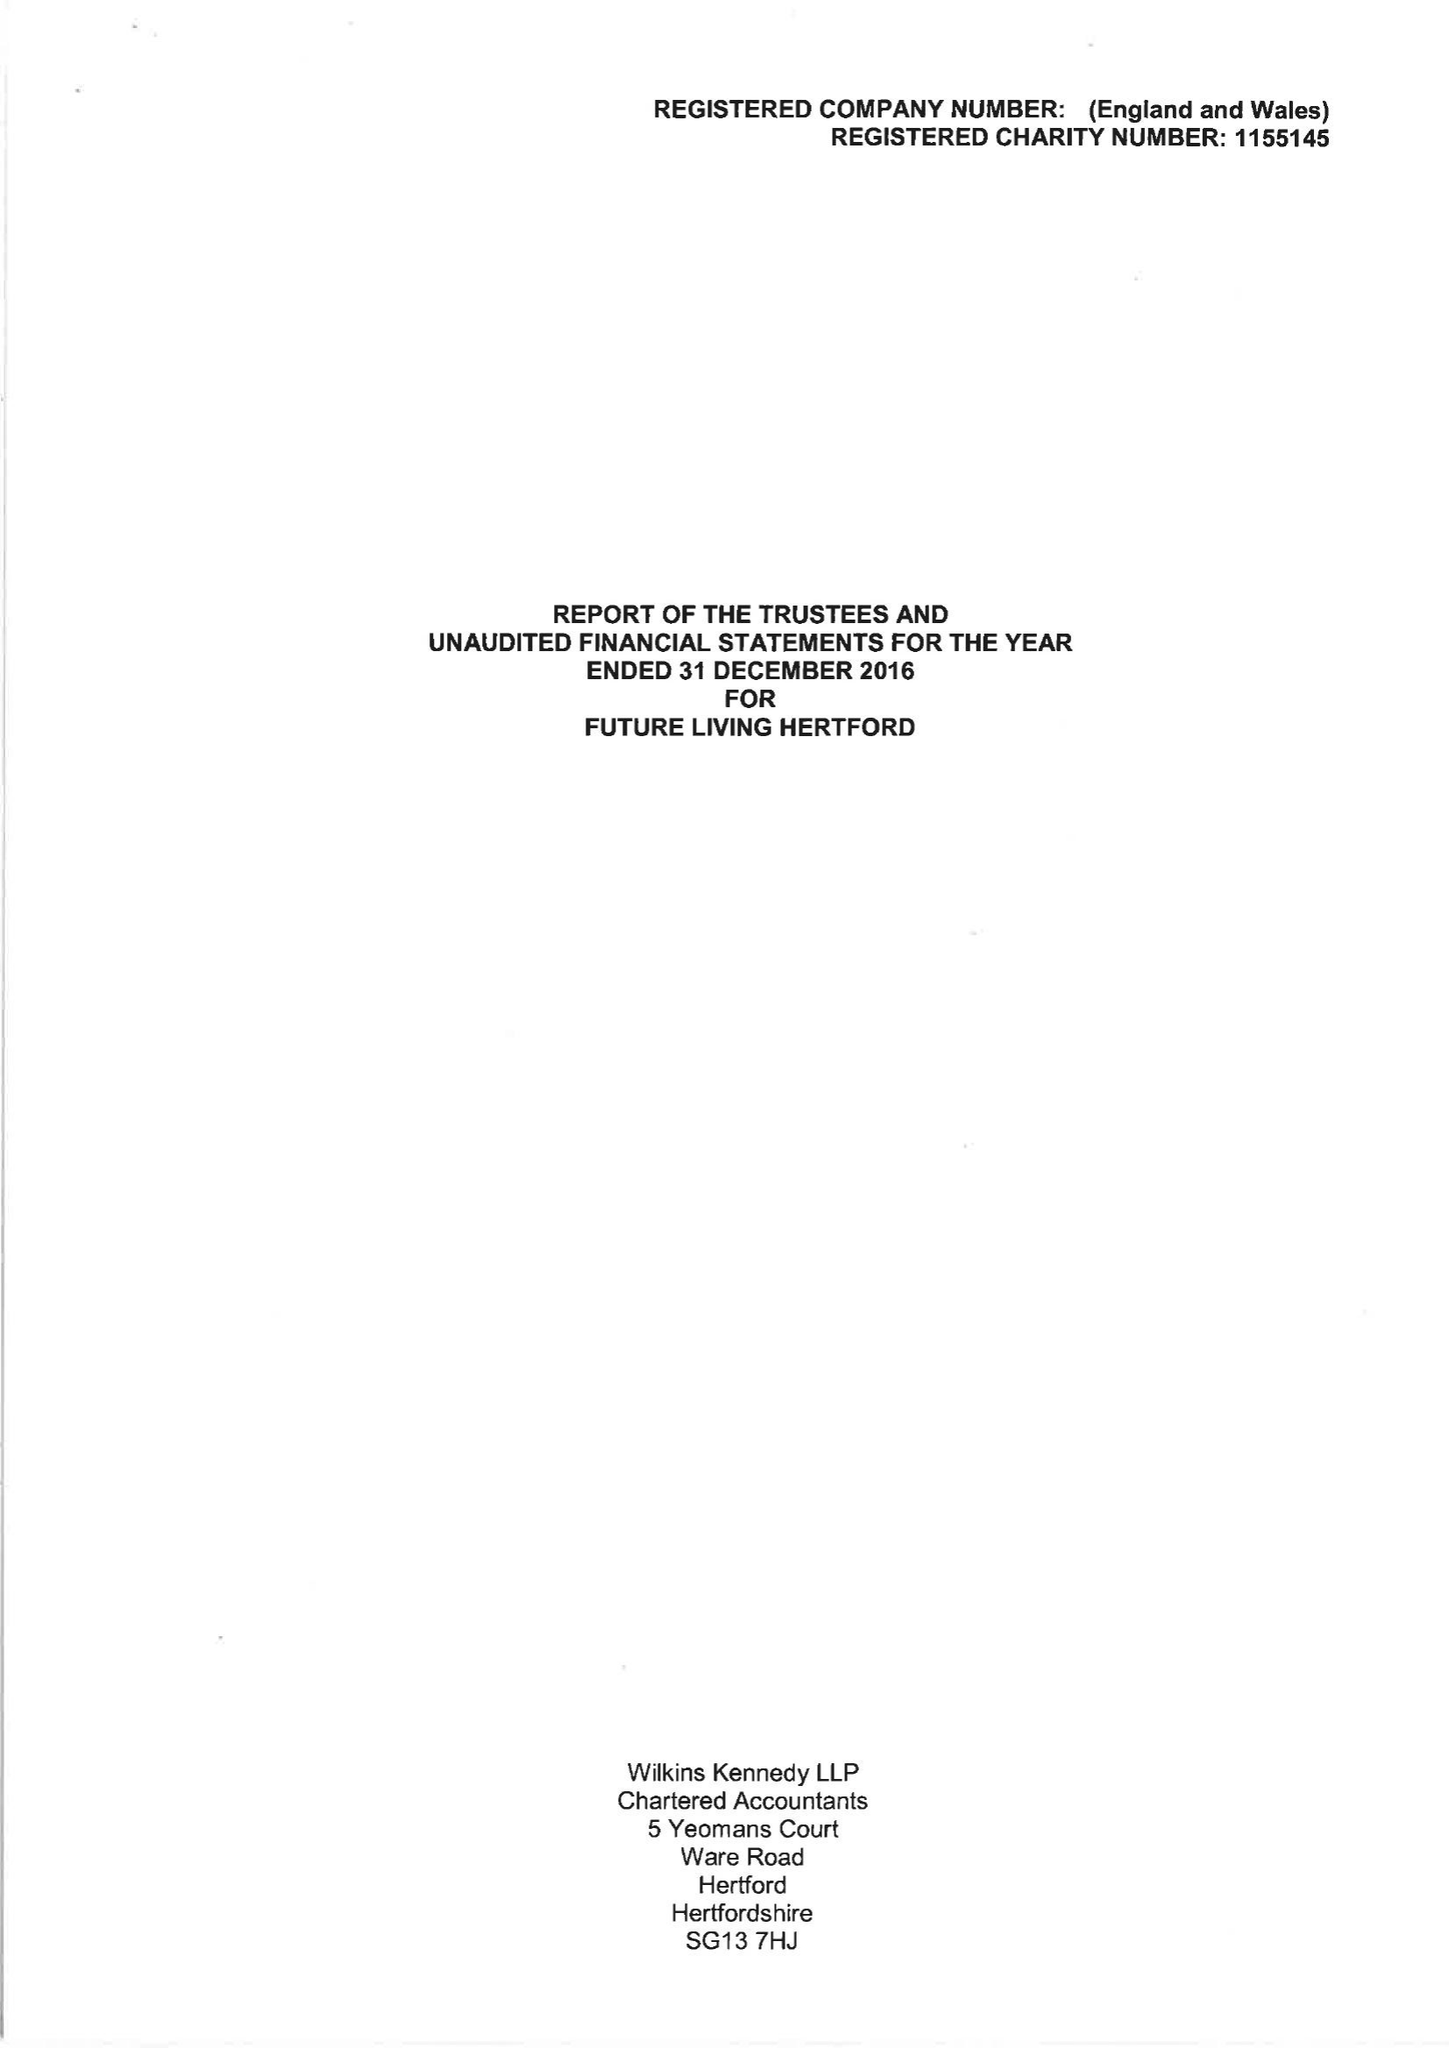What is the value for the address__street_line?
Answer the question using a single word or phrase. 43 COWBRIDGE 